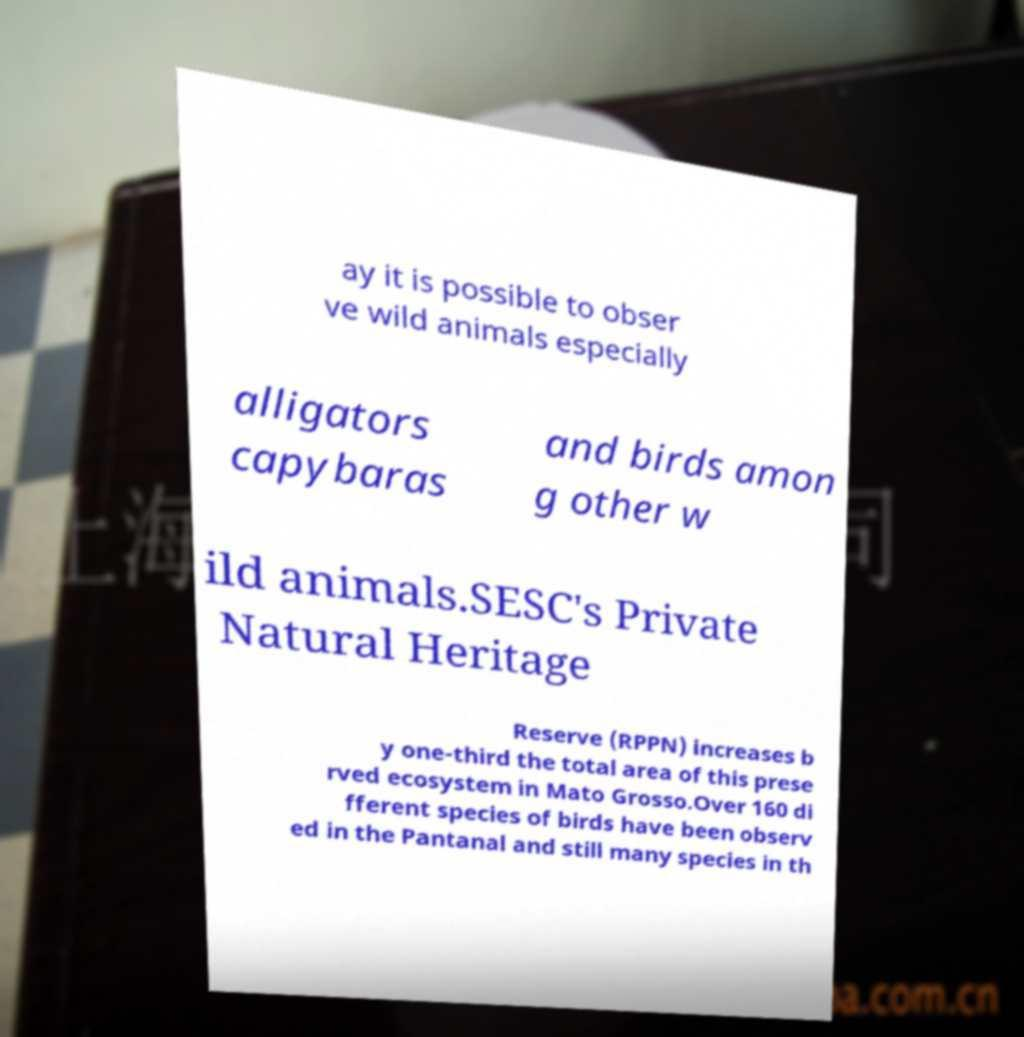For documentation purposes, I need the text within this image transcribed. Could you provide that? ay it is possible to obser ve wild animals especially alligators capybaras and birds amon g other w ild animals.SESC's Private Natural Heritage Reserve (RPPN) increases b y one-third the total area of this prese rved ecosystem in Mato Grosso.Over 160 di fferent species of birds have been observ ed in the Pantanal and still many species in th 